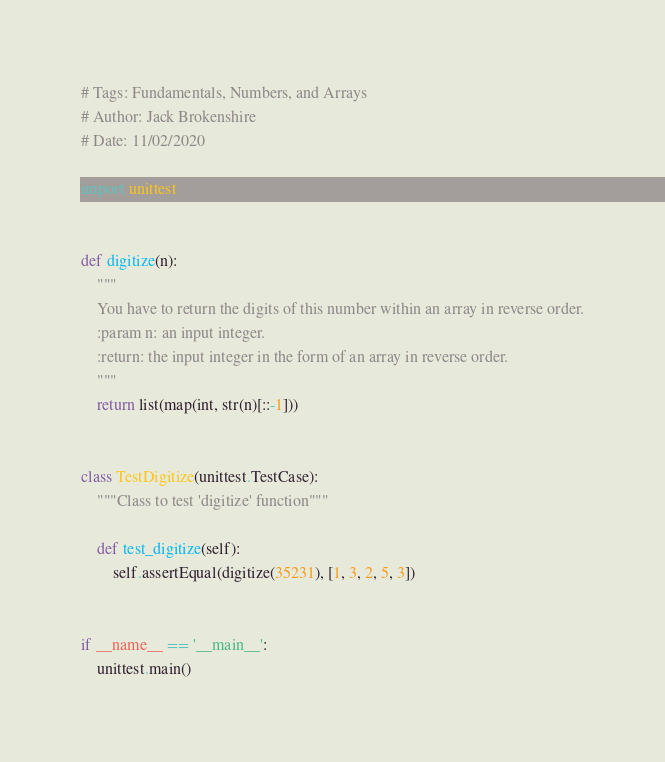<code> <loc_0><loc_0><loc_500><loc_500><_Python_># Tags: Fundamentals, Numbers, and Arrays
# Author: Jack Brokenshire
# Date: 11/02/2020

import unittest


def digitize(n):
    """
    You have to return the digits of this number within an array in reverse order.
    :param n: an input integer.
    :return: the input integer in the form of an array in reverse order.
    """
    return list(map(int, str(n)[::-1]))


class TestDigitize(unittest.TestCase):
    """Class to test 'digitize' function"""

    def test_digitize(self):
        self.assertEqual(digitize(35231), [1, 3, 2, 5, 3])


if __name__ == '__main__':
    unittest.main()
</code> 